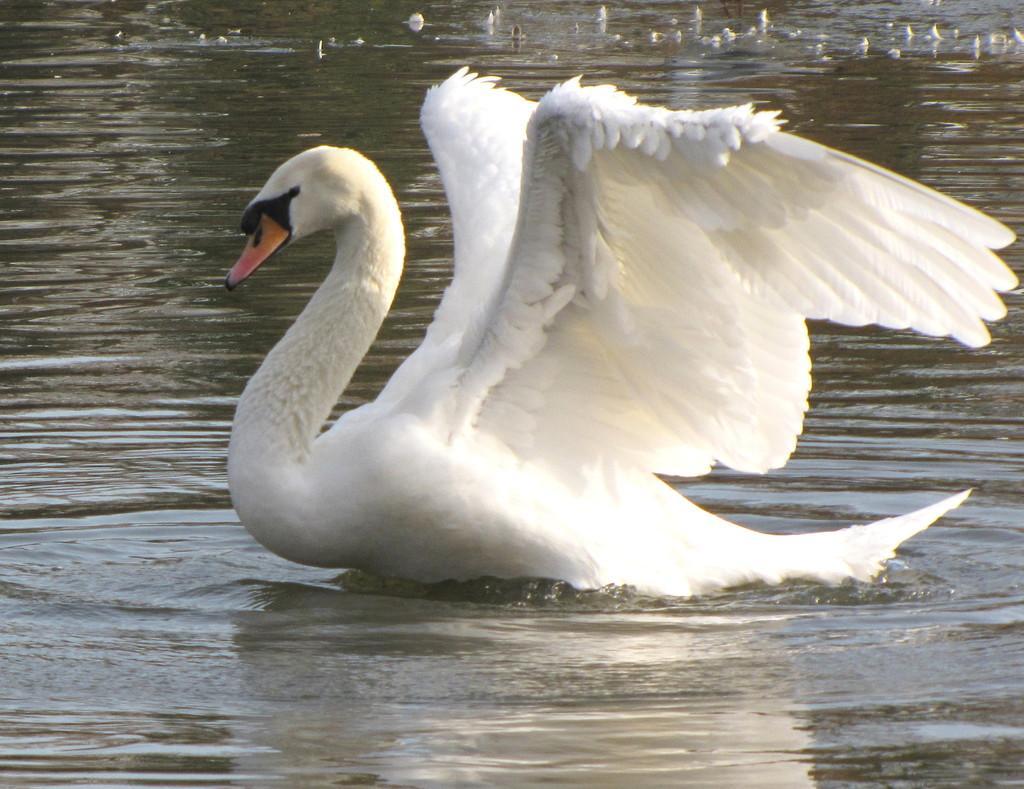How would you summarize this image in a sentence or two? In this picture we can see a swan on the water. 